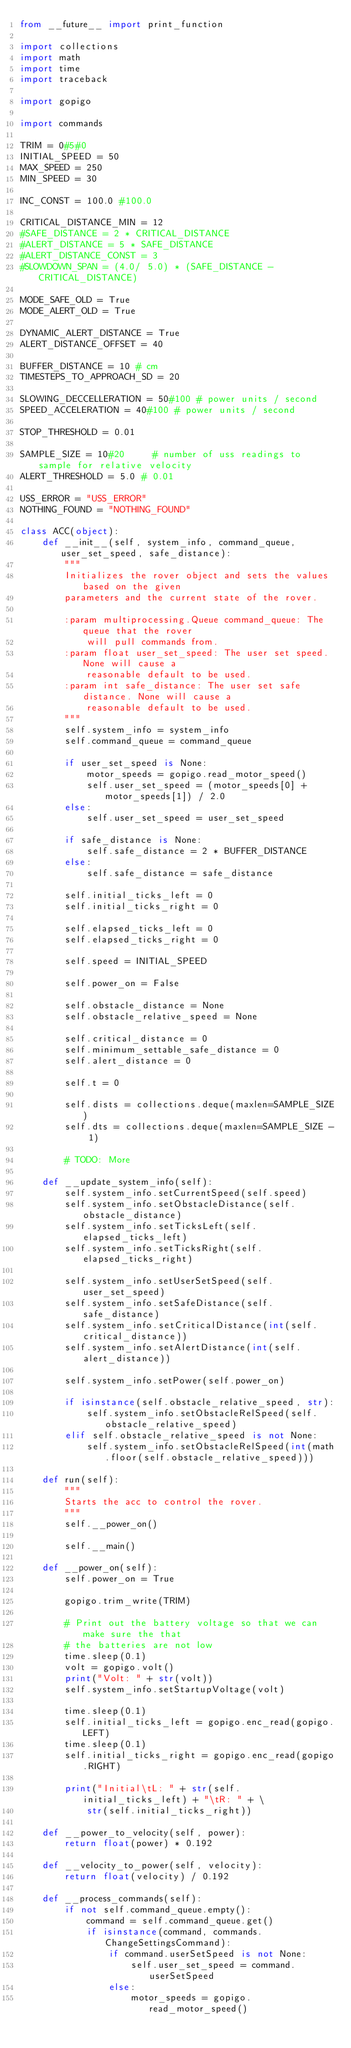<code> <loc_0><loc_0><loc_500><loc_500><_Python_>from __future__ import print_function

import collections
import math
import time
import traceback

import gopigo

import commands

TRIM = 0#5#0
INITIAL_SPEED = 50
MAX_SPEED = 250
MIN_SPEED = 30

INC_CONST = 100.0 #100.0

CRITICAL_DISTANCE_MIN = 12
#SAFE_DISTANCE = 2 * CRITICAL_DISTANCE
#ALERT_DISTANCE = 5 * SAFE_DISTANCE
#ALERT_DISTANCE_CONST = 3
#SLOWDOWN_SPAN = (4.0/ 5.0) * (SAFE_DISTANCE - CRITICAL_DISTANCE)

MODE_SAFE_OLD = True
MODE_ALERT_OLD = True

DYNAMIC_ALERT_DISTANCE = True
ALERT_DISTANCE_OFFSET = 40

BUFFER_DISTANCE = 10 # cm
TIMESTEPS_TO_APPROACH_SD = 20

SLOWING_DECCELLERATION = 50#100 # power units / second
SPEED_ACCELERATION = 40#100 # power units / second

STOP_THRESHOLD = 0.01

SAMPLE_SIZE = 10#20     # number of uss readings to sample for relative velocity
ALERT_THRESHOLD = 5.0 # 0.01

USS_ERROR = "USS_ERROR"
NOTHING_FOUND = "NOTHING_FOUND"

class ACC(object):
    def __init__(self, system_info, command_queue, user_set_speed, safe_distance):
        """
        Initializes the rover object and sets the values based on the given
        parameters and the current state of the rover.

        :param multiprocessing.Queue command_queue: The queue that the rover
            will pull commands from.
        :param float user_set_speed: The user set speed. None will cause a
            reasonable default to be used.
        :param int safe_distance: The user set safe distance. None will cause a
            reasonable default to be used.
        """
        self.system_info = system_info
        self.command_queue = command_queue

        if user_set_speed is None:
            motor_speeds = gopigo.read_motor_speed()
            self.user_set_speed = (motor_speeds[0] + motor_speeds[1]) / 2.0
        else:
            self.user_set_speed = user_set_speed

        if safe_distance is None:
            self.safe_distance = 2 * BUFFER_DISTANCE
        else:
            self.safe_distance = safe_distance

        self.initial_ticks_left = 0
        self.initial_ticks_right = 0

        self.elapsed_ticks_left = 0
        self.elapsed_ticks_right = 0

        self.speed = INITIAL_SPEED

        self.power_on = False

        self.obstacle_distance = None
        self.obstacle_relative_speed = None

        self.critical_distance = 0
        self.minimum_settable_safe_distance = 0
        self.alert_distance = 0

        self.t = 0

        self.dists = collections.deque(maxlen=SAMPLE_SIZE)
        self.dts = collections.deque(maxlen=SAMPLE_SIZE - 1)

        # TODO: More

    def __update_system_info(self):
        self.system_info.setCurrentSpeed(self.speed)
        self.system_info.setObstacleDistance(self.obstacle_distance)
        self.system_info.setTicksLeft(self.elapsed_ticks_left)
        self.system_info.setTicksRight(self.elapsed_ticks_right)

        self.system_info.setUserSetSpeed(self.user_set_speed)
        self.system_info.setSafeDistance(self.safe_distance)
        self.system_info.setCriticalDistance(int(self.critical_distance))
        self.system_info.setAlertDistance(int(self.alert_distance))

        self.system_info.setPower(self.power_on)

        if isinstance(self.obstacle_relative_speed, str):
            self.system_info.setObstacleRelSpeed(self.obstacle_relative_speed)
        elif self.obstacle_relative_speed is not None:
            self.system_info.setObstacleRelSpeed(int(math.floor(self.obstacle_relative_speed)))

    def run(self):
        """
        Starts the acc to control the rover.
        """
        self.__power_on()

        self.__main()

    def __power_on(self):
        self.power_on = True

        gopigo.trim_write(TRIM)

        # Print out the battery voltage so that we can make sure the that
        # the batteries are not low
        time.sleep(0.1)
        volt = gopigo.volt()
        print("Volt: " + str(volt))
        self.system_info.setStartupVoltage(volt)

        time.sleep(0.1)
        self.initial_ticks_left = gopigo.enc_read(gopigo.LEFT)
        time.sleep(0.1)
        self.initial_ticks_right = gopigo.enc_read(gopigo.RIGHT)

        print("Initial\tL: " + str(self.initial_ticks_left) + "\tR: " + \
            str(self.initial_ticks_right))

    def __power_to_velocity(self, power):
        return float(power) * 0.192

    def __velocity_to_power(self, velocity):
        return float(velocity) / 0.192

    def __process_commands(self):
        if not self.command_queue.empty():
            command = self.command_queue.get()
            if isinstance(command, commands.ChangeSettingsCommand):
                if command.userSetSpeed is not None:
                    self.user_set_speed = command.userSetSpeed
                else:
                    motor_speeds = gopigo.read_motor_speed()</code> 